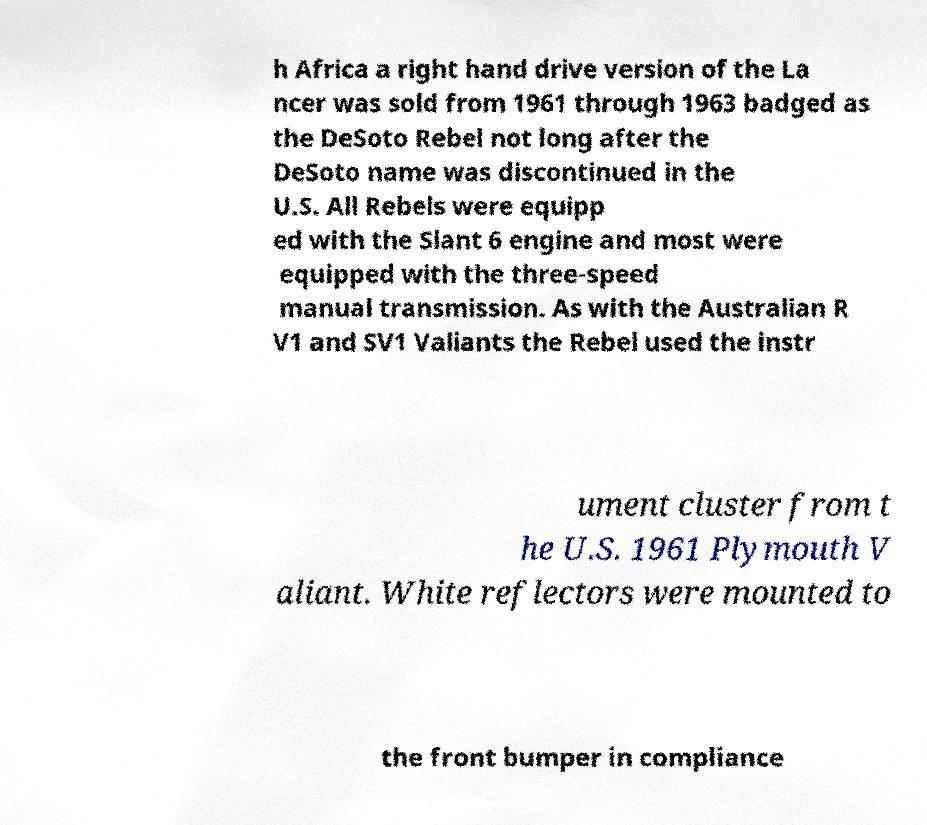Can you accurately transcribe the text from the provided image for me? h Africa a right hand drive version of the La ncer was sold from 1961 through 1963 badged as the DeSoto Rebel not long after the DeSoto name was discontinued in the U.S. All Rebels were equipp ed with the Slant 6 engine and most were equipped with the three-speed manual transmission. As with the Australian R V1 and SV1 Valiants the Rebel used the instr ument cluster from t he U.S. 1961 Plymouth V aliant. White reflectors were mounted to the front bumper in compliance 